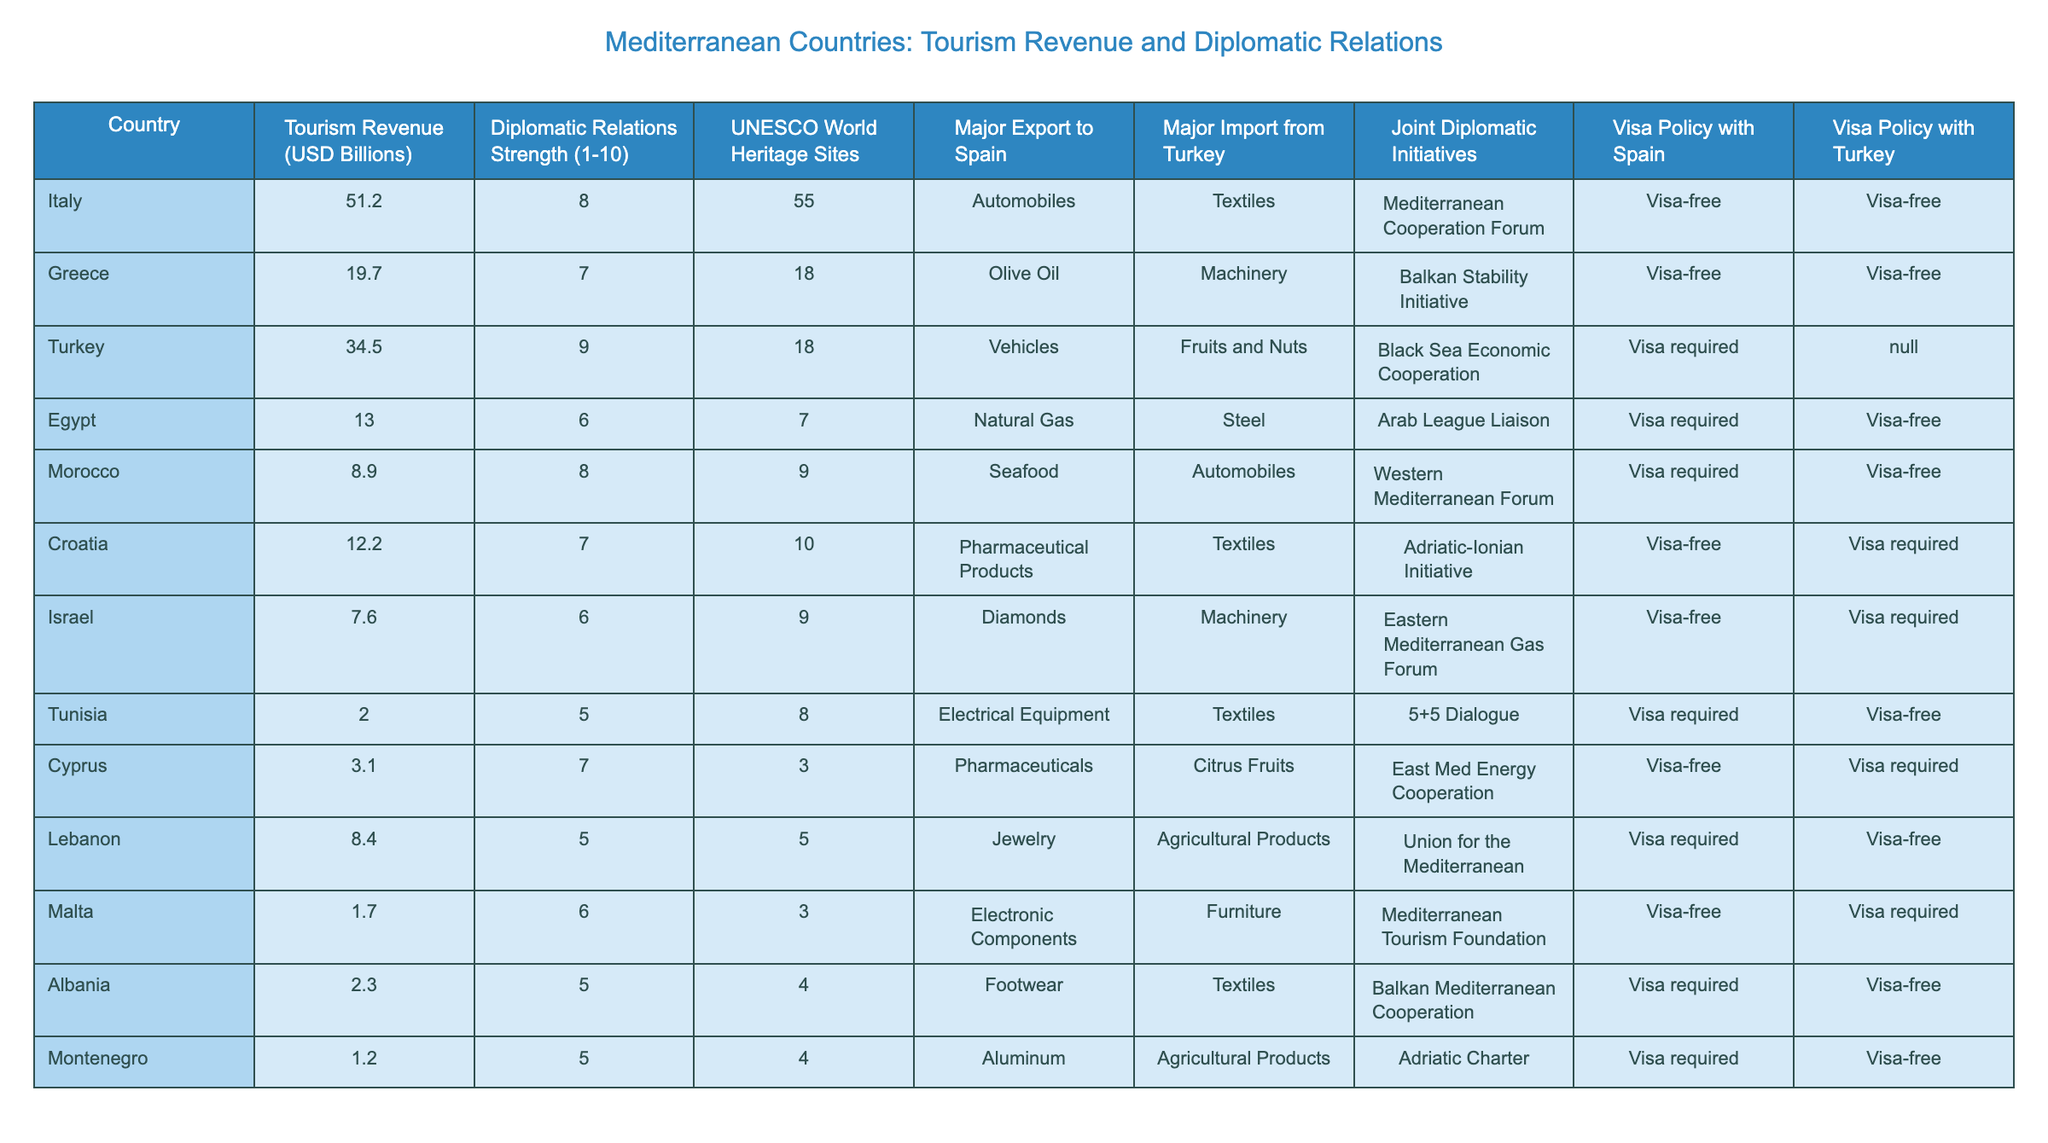What is the tourism revenue of Turkey? Turkey's tourism revenue is stated directly in the table as 34.5 billion USD.
Answer: 34.5 billion USD Which country has the highest diplomatic relations strength? The table lists diplomatic relations strength on a scale of 1 to 10, and Italy has the highest strength, which is 8.
Answer: Italy What is the average tourism revenue of the Mediterranean countries listed? By summing the tourism revenues of all the countries (51.2 + 19.7 + 34.5 + 13.0 + 8.9 + 12.2 + 7.6 + 2.0 + 3.1 + 8.4 + 1.7 + 2.3 + 1.2) =  179.7 billion USD, and dividing by the number of countries (13), the average tourism revenue is approximately 13.85 billion USD.
Answer: Approximately 13.85 billion USD Which country has both a visa-free policy with Spain and Turkey? Looking at the visa policy with Spain and Turkey, Greece is the only country that has a visa-free policy with both.
Answer: Greece Is Morocco's major export to Spain automobiles? The table clearly states that Morocco's major export to Spain is seafood, not automobiles. Therefore, the statement is false.
Answer: No What is the total tourism revenue of countries with a diplomatic relations strength of 5? Summing the tourism revenues for countries with a strength of 5 (Tunisia (2.0) + Lebanon (8.4) + Albania (2.3) + Montenegro (1.2)) gives a total of 13.9 billion USD.
Answer: 13.9 billion USD How many UNESCO World Heritage Sites does Italy have compared to Tunisia? Italy has 55 UNESCO World Heritage Sites, while Tunisia has 8. The difference is 47 (55 - 8).
Answer: 47 Which countries require a visa from Spain and have a strength of 6? Turkey has a visa required policy with Spain, but it has a strength of 9. Egypt requires a visa and has a strength of 6. Therefore, the only country meeting the criteria is Egypt.
Answer: Egypt What is the total number of UNESCO World Heritage Sites among the countries listed? Adding the UNESCO World Heritage Sites for all countries (55 + 18 + 18 + 7 + 9 + 10 + 9 + 8 + 3 + 5 + 3 + 4 + 4) equals  179 UNESCO World Heritage Sites in total.
Answer: 179 Which country has the lowest tourism revenue and what is that revenue? The table shows that Malta has the lowest tourism revenue at 1.7 billion USD.
Answer: 1.7 billion USD 